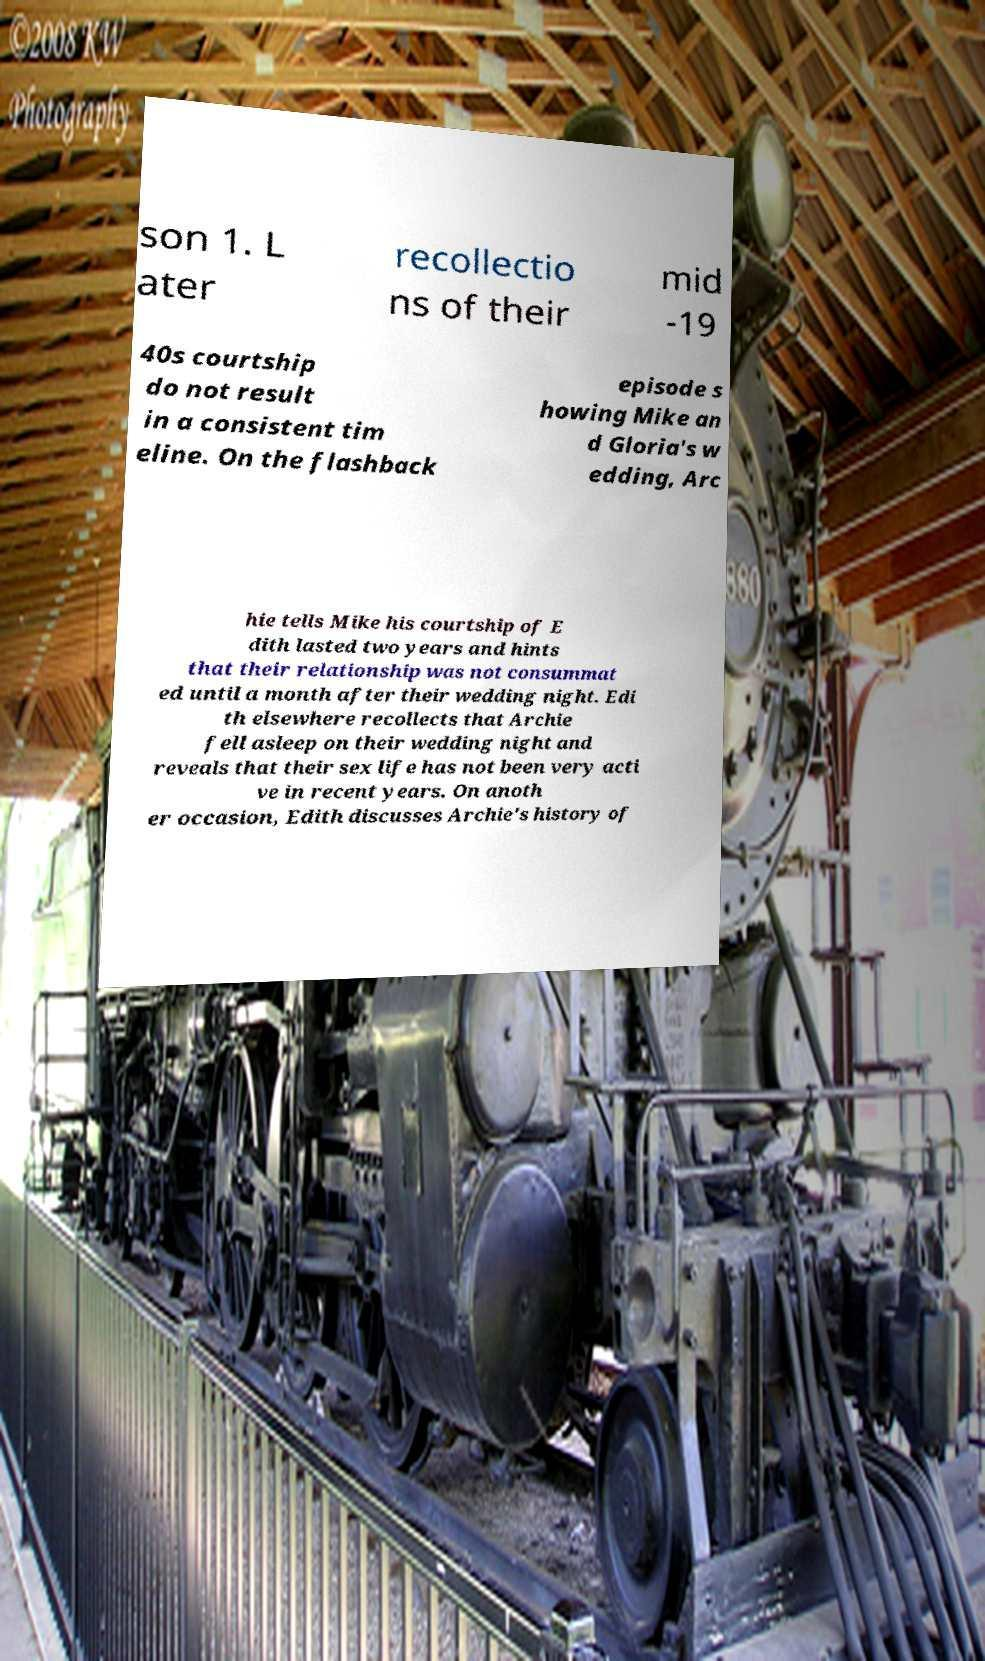For documentation purposes, I need the text within this image transcribed. Could you provide that? son 1. L ater recollectio ns of their mid -19 40s courtship do not result in a consistent tim eline. On the flashback episode s howing Mike an d Gloria's w edding, Arc hie tells Mike his courtship of E dith lasted two years and hints that their relationship was not consummat ed until a month after their wedding night. Edi th elsewhere recollects that Archie fell asleep on their wedding night and reveals that their sex life has not been very acti ve in recent years. On anoth er occasion, Edith discusses Archie's history of 